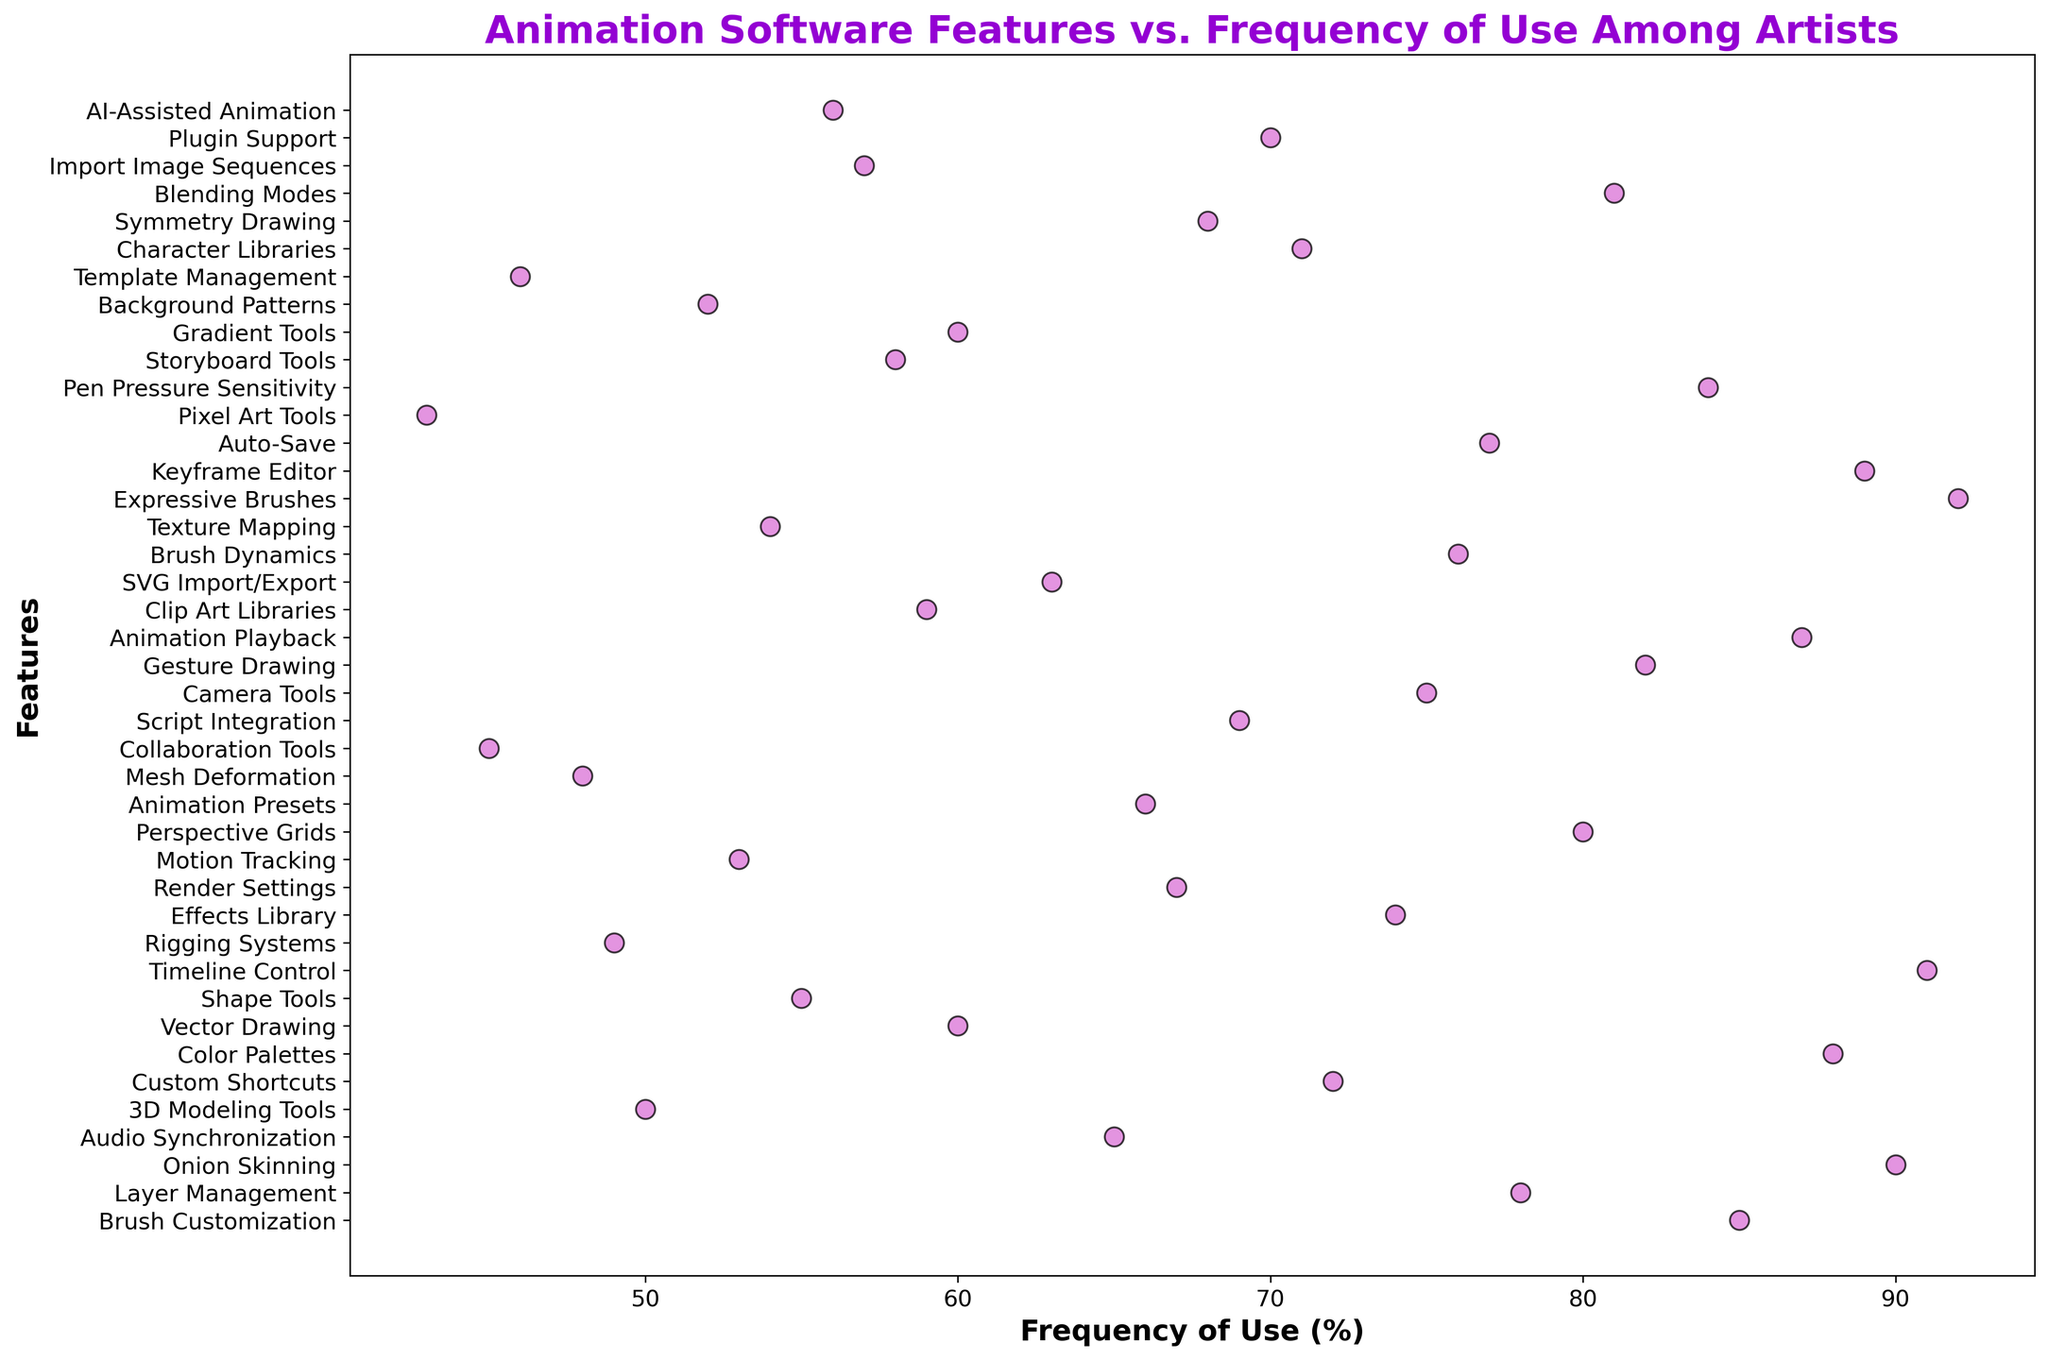Which feature has the highest frequency of use? The feature with the highest frequency of use is the one that has the furthest point to the right on the x-axis. For this plot, it's "Expressive Brushes" with a frequency of 92.
Answer: Expressive Brushes Which feature has the lowest frequency of use? The feature with the lowest frequency of use is the one that has the furthest point to the left on the x-axis. For this plot, it's "Pixel Art Tools" with a frequency of 43.
Answer: Pixel Art Tools Which two features have nearly the same frequency of use and what are their values? To find two features with nearly the same frequency, look for points that are close together on the x-axis. "Gradient Tools" and "Vector Drawing" are close, both having frequencies of 60.
Answer: Gradient Tools and Vector Drawing, 60 What is the average frequency of use for the top 5 most frequently used features? Identify the top 5 highest frequencies and calculate their average: "Expressive Brushes" (92), "Timeline Control" (91), "Keyframe Editor" (89), "Animation Playback" (87), "Color Palettes" (88). Calculating the average: (92 + 91 + 89 + 87 + 88) / 5 = 89.4
Answer: 89.4 How many features have a frequency of use above 70%? Count the number of points that are to the right of the 70 mark on the x-axis. These features are “Expressive Brushes,” “Timeline Control,” “Keyframe Editor,” “Animation Playback,” “Color Palettes,” “Pen Pressure Sensitivity,” “Gesture Drawing,” “Blending Modes,” “Brush Customization,” “Brush Dynamics,” “Auto-Save,” “Layer Management,” “Camera Tools,” and “Effects Library.” There are 14 features.
Answer: 14 Between "3D Modeling Tools" and "Rigging Systems", which feature is more frequently used and by what margin? Compare the positions of these points on the x-axis. "3D Modeling Tools" has a frequency of 50, and "Rigging Systems" has 49. The difference is 50 - 49 = 1.
Answer: 3D Modeling Tools by 1 How many features have a frequency of use below 50%, and which are they? Count the points left of the 50 mark on the x-axis. They are “Pixel Art Tools,” “Collaboration Tools,” “Mesh Deformation,” “Template Management,” and “Rigging Systems.” There are 5 features.
Answer: 5 features: Pixel Art Tools, Collaboration Tools, Mesh Deformation, Template Management, Rigging Systems Which feature has a frequency closest to the median value, and what is that frequency? After sorting the frequencies and finding the median value (which is between the 20th and 21st values), we see the median is between 67 and 68. The feature nearest these values is "Render Settings" with a frequency of 67.
Answer: Render Settings, 67 